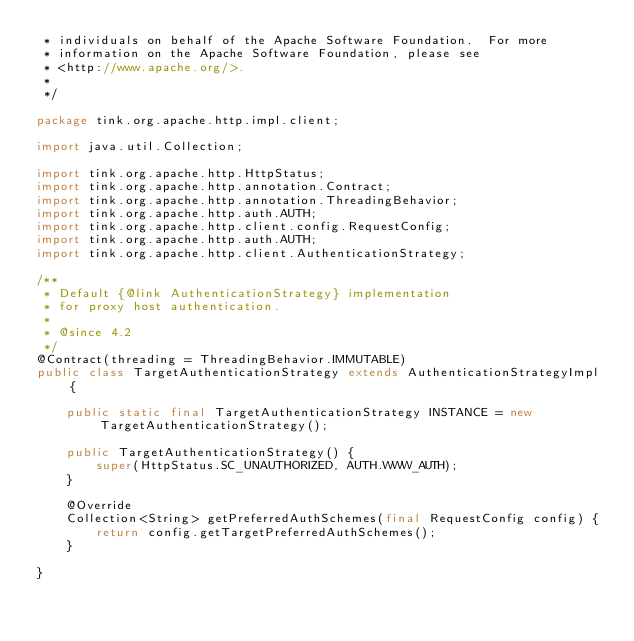Convert code to text. <code><loc_0><loc_0><loc_500><loc_500><_Java_> * individuals on behalf of the Apache Software Foundation.  For more
 * information on the Apache Software Foundation, please see
 * <http://www.apache.org/>.
 *
 */

package tink.org.apache.http.impl.client;

import java.util.Collection;

import tink.org.apache.http.HttpStatus;
import tink.org.apache.http.annotation.Contract;
import tink.org.apache.http.annotation.ThreadingBehavior;
import tink.org.apache.http.auth.AUTH;
import tink.org.apache.http.client.config.RequestConfig;
import tink.org.apache.http.auth.AUTH;
import tink.org.apache.http.client.AuthenticationStrategy;

/**
 * Default {@link AuthenticationStrategy} implementation
 * for proxy host authentication.
 *
 * @since 4.2
 */
@Contract(threading = ThreadingBehavior.IMMUTABLE)
public class TargetAuthenticationStrategy extends AuthenticationStrategyImpl {

    public static final TargetAuthenticationStrategy INSTANCE = new TargetAuthenticationStrategy();

    public TargetAuthenticationStrategy() {
        super(HttpStatus.SC_UNAUTHORIZED, AUTH.WWW_AUTH);
    }

    @Override
    Collection<String> getPreferredAuthSchemes(final RequestConfig config) {
        return config.getTargetPreferredAuthSchemes();
    }

}
</code> 